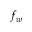Convert formula to latex. <formula><loc_0><loc_0><loc_500><loc_500>f _ { w }</formula> 